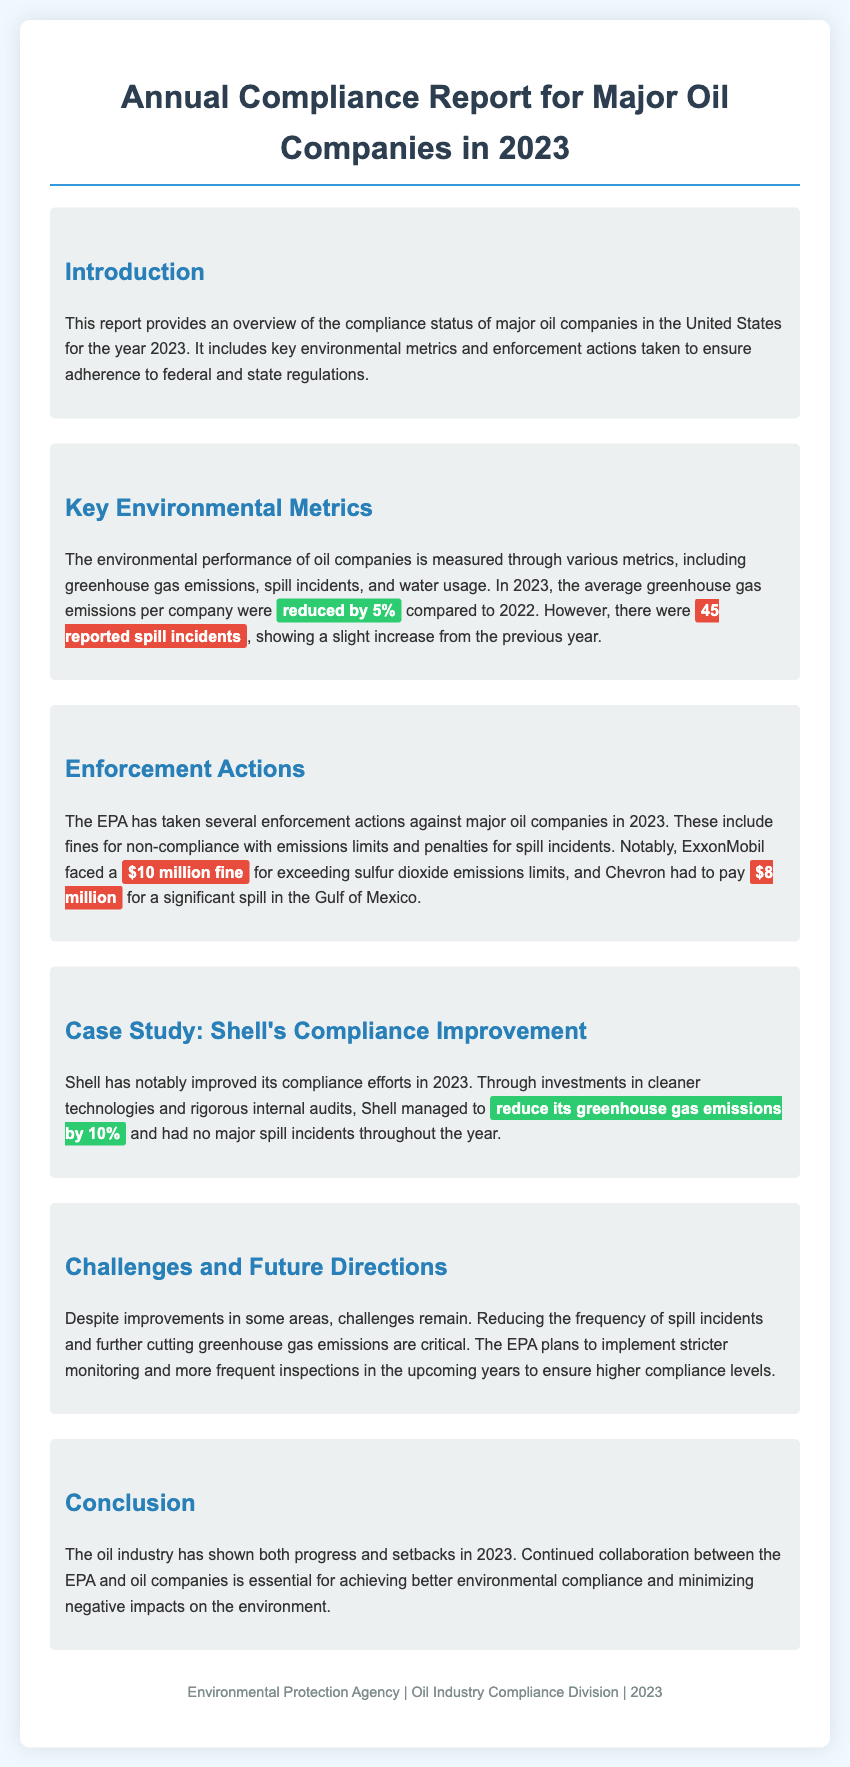What was the average greenhouse gas emissions reduction for oil companies in 2023? The document states that the average greenhouse gas emissions per company were reduced by 5% compared to 2022.
Answer: 5% How many reported spill incidents occurred in 2023? The report mentions that there were 45 reported spill incidents in 2023, which indicates a slight increase from the previous year.
Answer: 45 What was the fine imposed on ExxonMobil for exceeding sulfur dioxide emissions limits? The report specifies that ExxonMobil faced a fine of $10 million for non-compliance with emissions limits.
Answer: $10 million Which company had no major spill incidents in 2023? According to the case study, Shell had no major spill incidents throughout the year 2023.
Answer: Shell What percentage did Shell reduce its greenhouse gas emissions by in 2023? The case study notes that Shell managed to reduce its greenhouse gas emissions by 10% in 2023.
Answer: 10% What are the two key challenges mentioned for the oil industry? The document identifies that reducing the frequency of spill incidents and further cutting greenhouse gas emissions are critical challenges.
Answer: Spill incidents and greenhouse gas emissions What will the EPA implement in the upcoming years to ensure higher compliance levels? The document states that the EPA plans to implement stricter monitoring and more frequent inspections to ensure better compliance.
Answer: Stricter monitoring and inspections What was the total penalty imposed on Chevron for a significant spill? The report states that Chevron had to pay $8 million for a significant spill in the Gulf of Mexico.
Answer: $8 million 